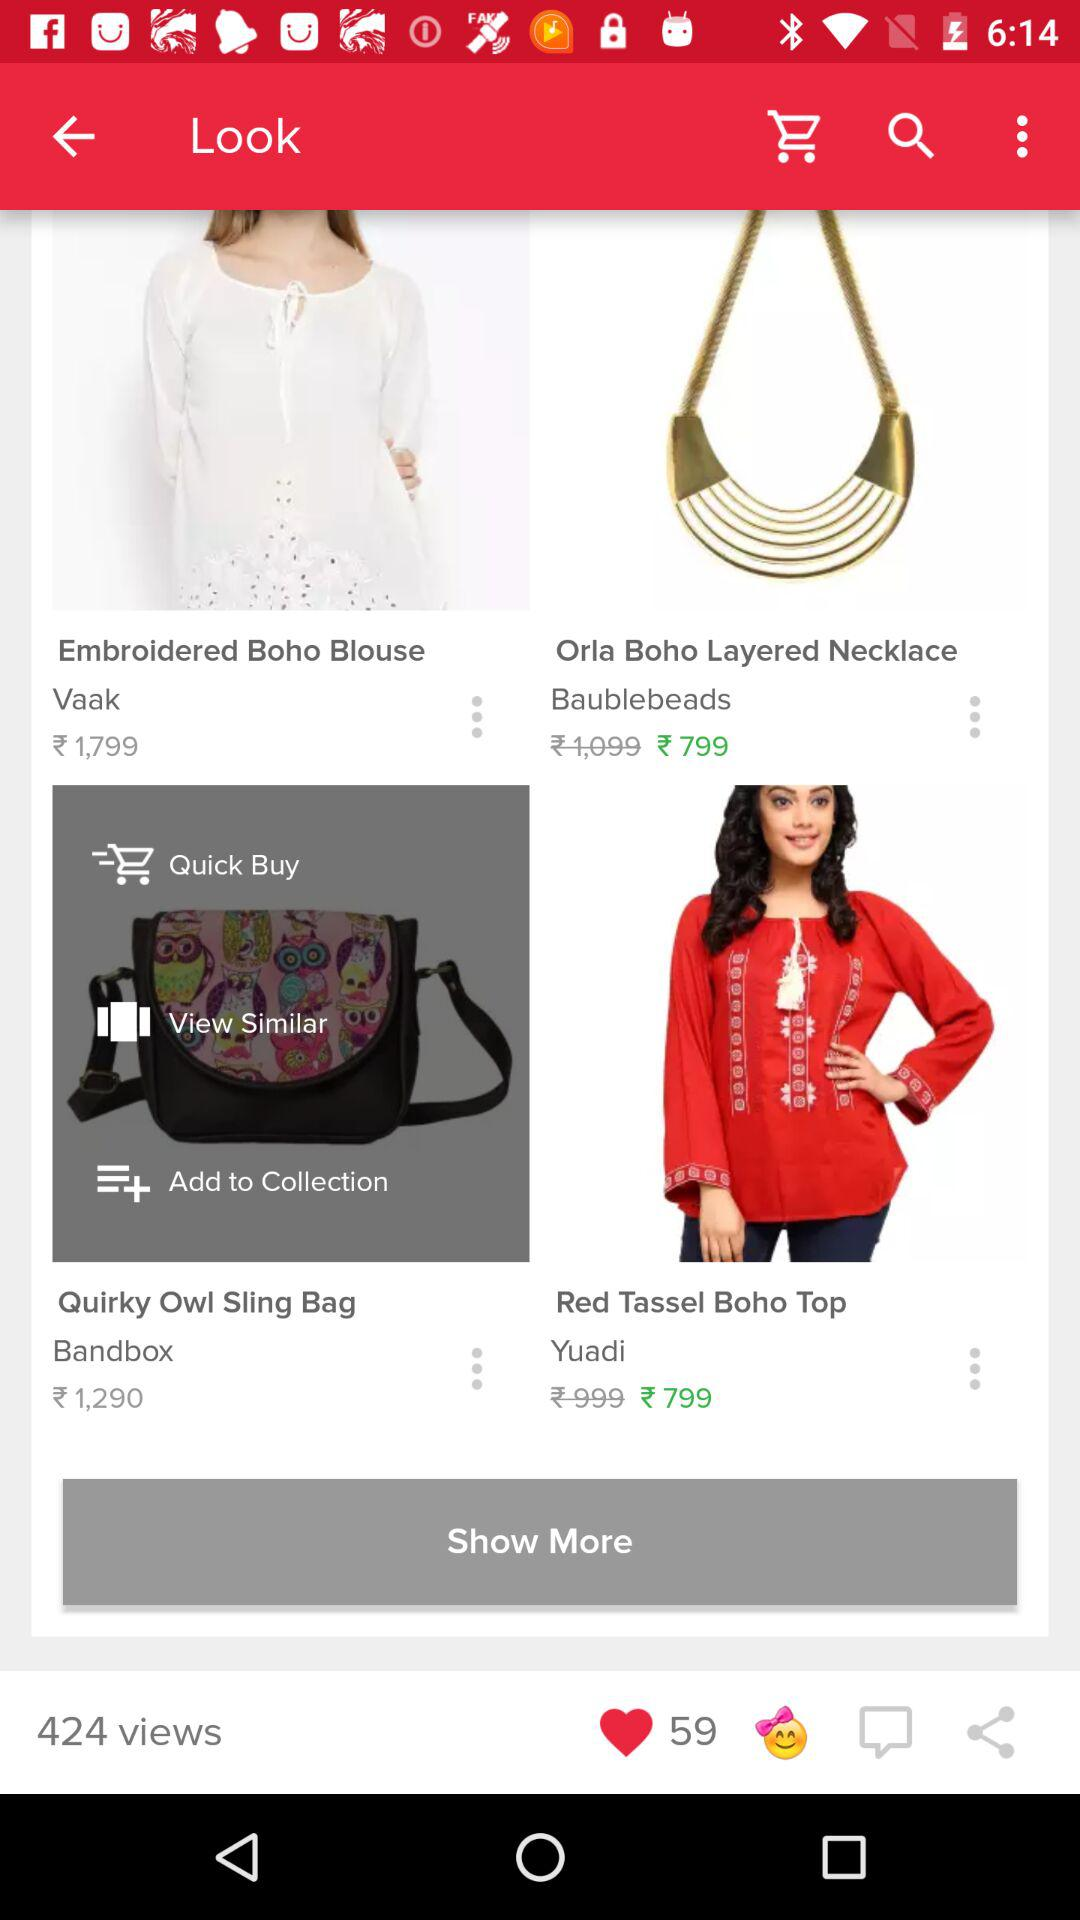What is the price of the "Sling Bag"? The price of the "Sling Bag" is ₹1,290. 